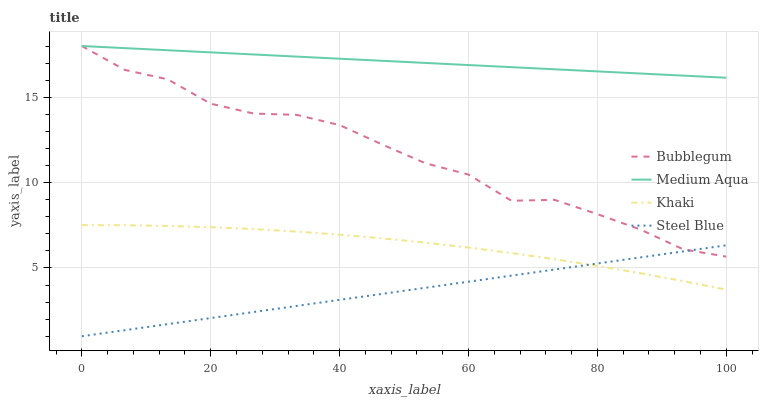Does Steel Blue have the minimum area under the curve?
Answer yes or no. Yes. Does Medium Aqua have the maximum area under the curve?
Answer yes or no. Yes. Does Medium Aqua have the minimum area under the curve?
Answer yes or no. No. Does Steel Blue have the maximum area under the curve?
Answer yes or no. No. Is Medium Aqua the smoothest?
Answer yes or no. Yes. Is Bubblegum the roughest?
Answer yes or no. Yes. Is Steel Blue the smoothest?
Answer yes or no. No. Is Steel Blue the roughest?
Answer yes or no. No. Does Medium Aqua have the lowest value?
Answer yes or no. No. Does Bubblegum have the highest value?
Answer yes or no. Yes. Does Steel Blue have the highest value?
Answer yes or no. No. Is Khaki less than Medium Aqua?
Answer yes or no. Yes. Is Bubblegum greater than Khaki?
Answer yes or no. Yes. Does Khaki intersect Medium Aqua?
Answer yes or no. No. 